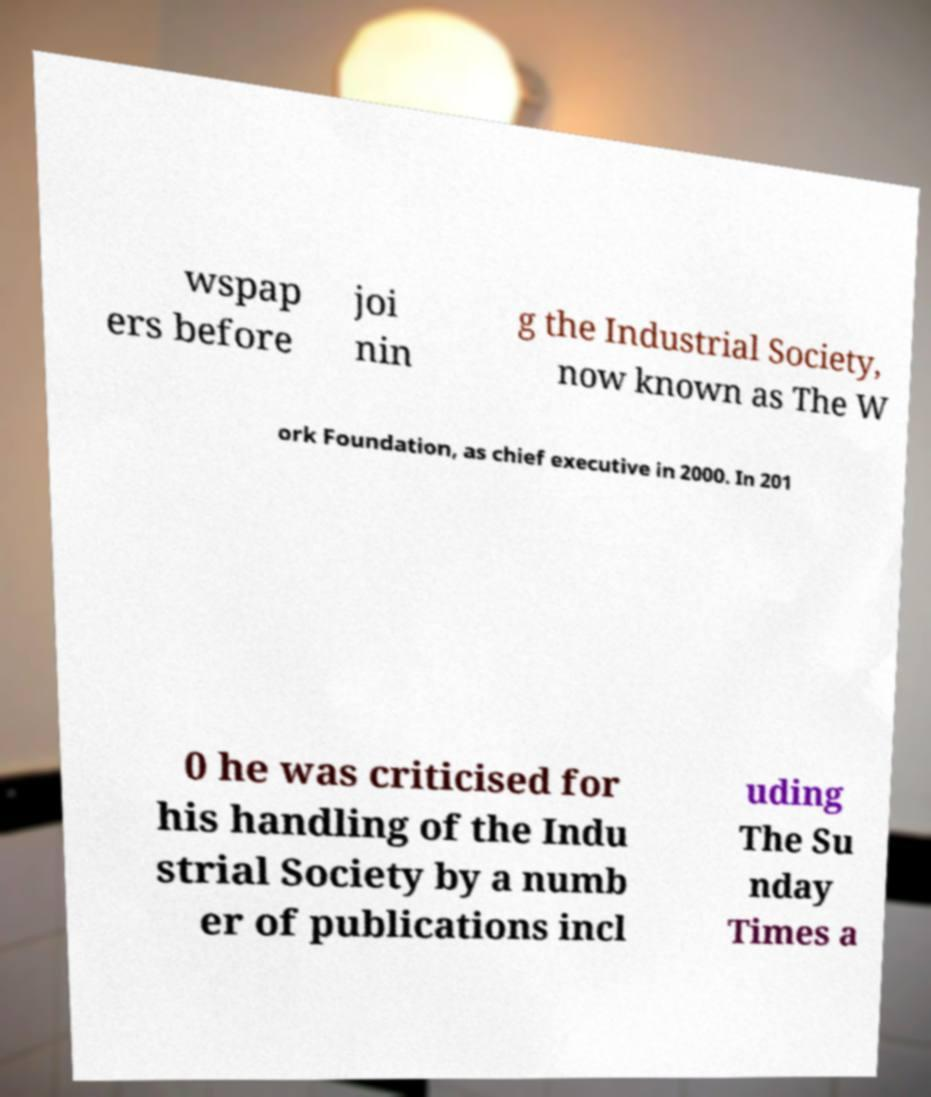Could you assist in decoding the text presented in this image and type it out clearly? wspap ers before joi nin g the Industrial Society, now known as The W ork Foundation, as chief executive in 2000. In 201 0 he was criticised for his handling of the Indu strial Society by a numb er of publications incl uding The Su nday Times a 